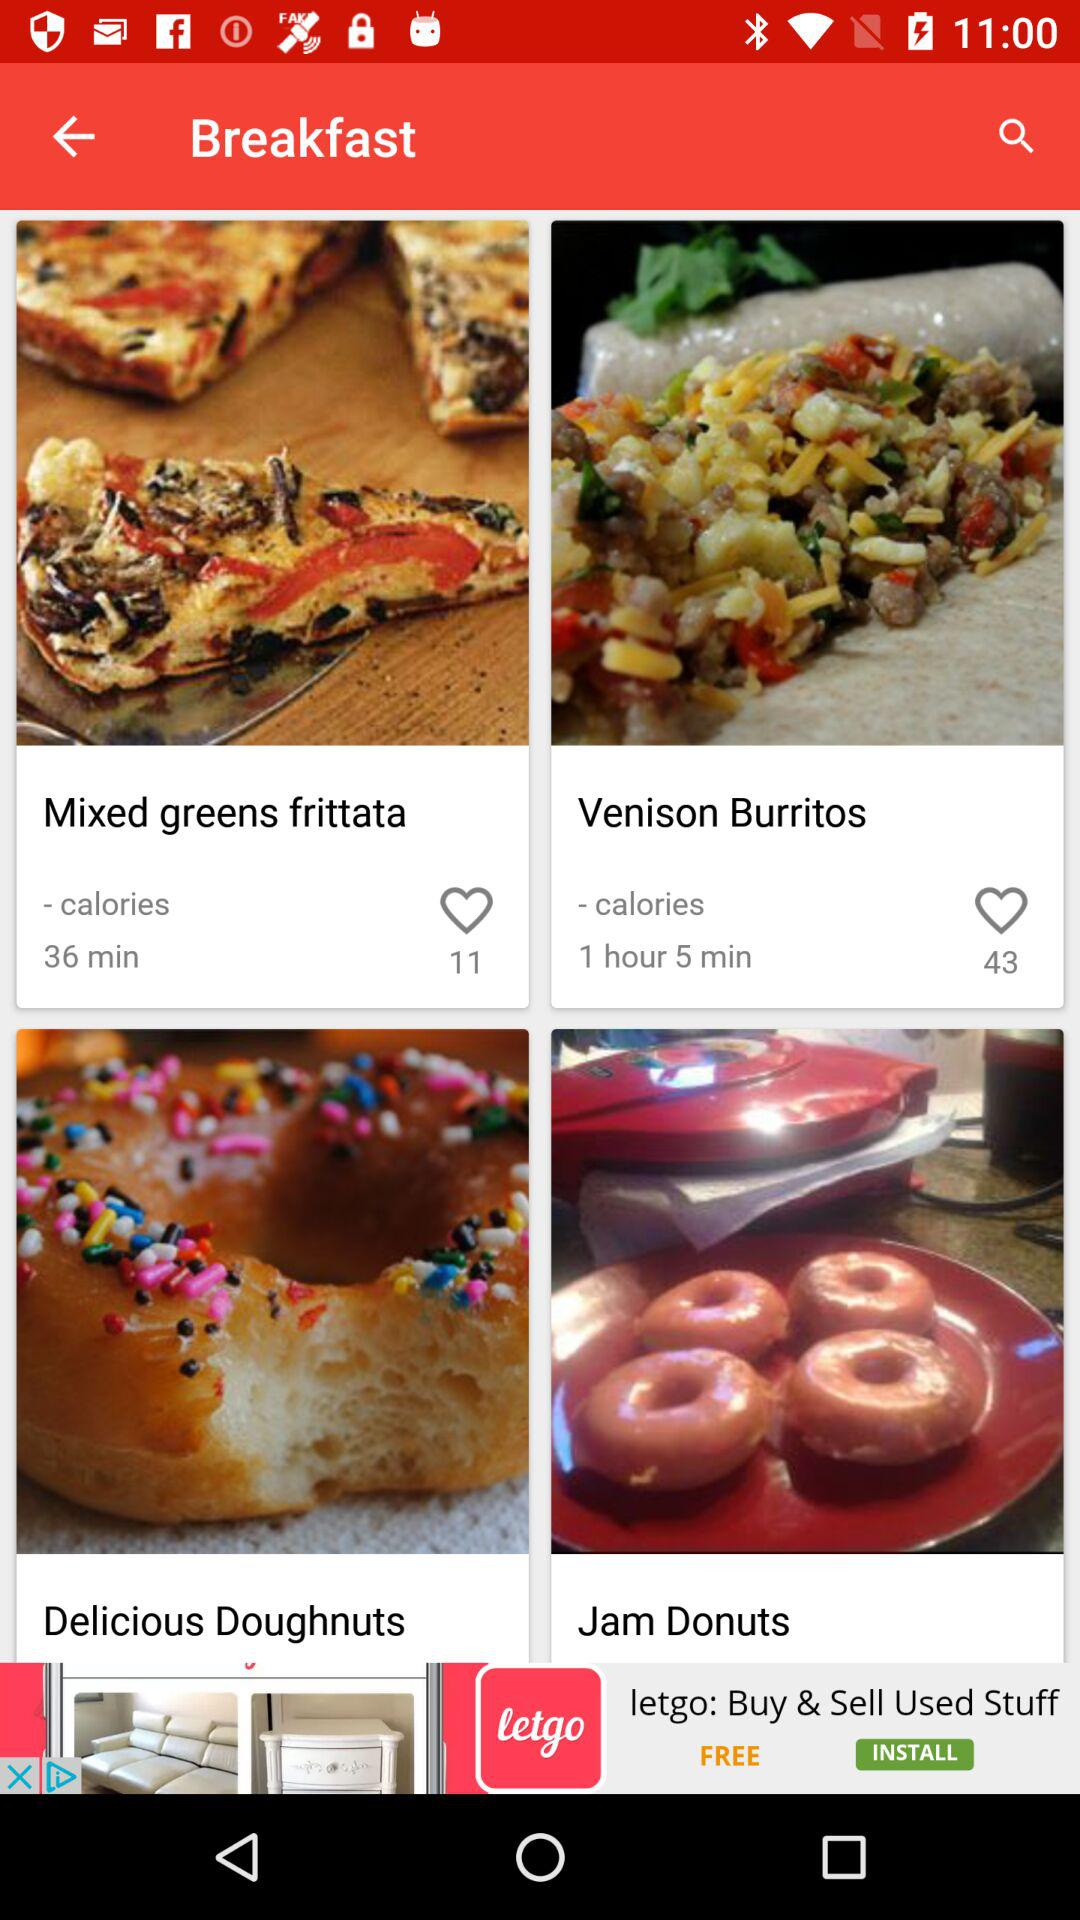What is the preparation time for the mixed greens frittata? The preparation time for the mixed greens frittata is 36 minutes. 